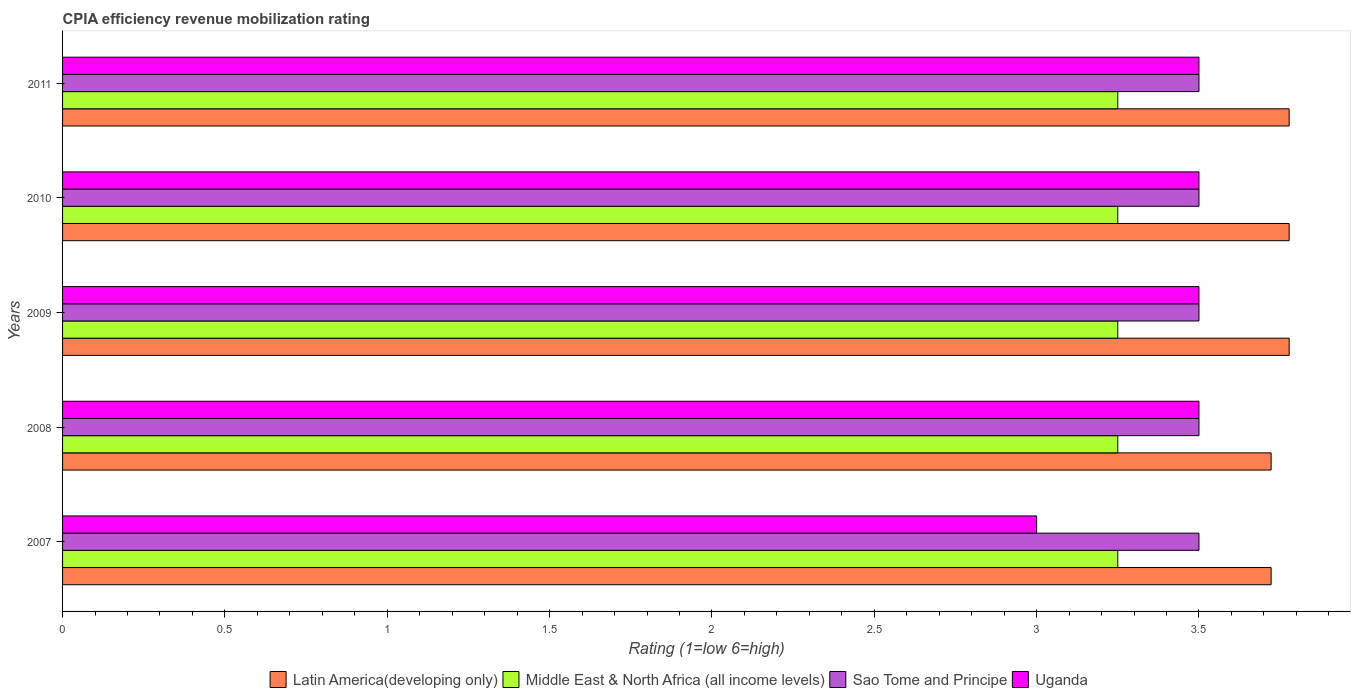How many different coloured bars are there?
Your answer should be very brief. 4. Are the number of bars on each tick of the Y-axis equal?
Offer a very short reply. Yes. How many bars are there on the 5th tick from the top?
Offer a very short reply. 4. Across all years, what is the minimum CPIA rating in Latin America(developing only)?
Give a very brief answer. 3.72. In which year was the CPIA rating in Uganda maximum?
Make the answer very short. 2008. In which year was the CPIA rating in Middle East & North Africa (all income levels) minimum?
Keep it short and to the point. 2007. What is the difference between the CPIA rating in Middle East & North Africa (all income levels) in 2007 and that in 2009?
Your answer should be compact. 0. What is the difference between the CPIA rating in Uganda in 2010 and the CPIA rating in Sao Tome and Principe in 2007?
Your answer should be very brief. 0. In the year 2008, what is the difference between the CPIA rating in Middle East & North Africa (all income levels) and CPIA rating in Sao Tome and Principe?
Offer a terse response. -0.25. What is the ratio of the CPIA rating in Middle East & North Africa (all income levels) in 2007 to that in 2011?
Give a very brief answer. 1. Is the CPIA rating in Latin America(developing only) in 2007 less than that in 2010?
Give a very brief answer. Yes. Is the difference between the CPIA rating in Middle East & North Africa (all income levels) in 2010 and 2011 greater than the difference between the CPIA rating in Sao Tome and Principe in 2010 and 2011?
Your response must be concise. No. What does the 1st bar from the top in 2007 represents?
Provide a short and direct response. Uganda. What does the 2nd bar from the bottom in 2011 represents?
Your answer should be compact. Middle East & North Africa (all income levels). Is it the case that in every year, the sum of the CPIA rating in Middle East & North Africa (all income levels) and CPIA rating in Uganda is greater than the CPIA rating in Sao Tome and Principe?
Keep it short and to the point. Yes. Are all the bars in the graph horizontal?
Make the answer very short. Yes. How many years are there in the graph?
Offer a terse response. 5. What is the difference between two consecutive major ticks on the X-axis?
Give a very brief answer. 0.5. How many legend labels are there?
Your answer should be compact. 4. How are the legend labels stacked?
Offer a terse response. Horizontal. What is the title of the graph?
Provide a succinct answer. CPIA efficiency revenue mobilization rating. What is the label or title of the X-axis?
Offer a very short reply. Rating (1=low 6=high). What is the label or title of the Y-axis?
Give a very brief answer. Years. What is the Rating (1=low 6=high) in Latin America(developing only) in 2007?
Make the answer very short. 3.72. What is the Rating (1=low 6=high) of Middle East & North Africa (all income levels) in 2007?
Offer a very short reply. 3.25. What is the Rating (1=low 6=high) in Sao Tome and Principe in 2007?
Provide a short and direct response. 3.5. What is the Rating (1=low 6=high) in Uganda in 2007?
Your answer should be very brief. 3. What is the Rating (1=low 6=high) in Latin America(developing only) in 2008?
Your response must be concise. 3.72. What is the Rating (1=low 6=high) of Uganda in 2008?
Give a very brief answer. 3.5. What is the Rating (1=low 6=high) of Latin America(developing only) in 2009?
Keep it short and to the point. 3.78. What is the Rating (1=low 6=high) in Latin America(developing only) in 2010?
Your answer should be compact. 3.78. What is the Rating (1=low 6=high) in Sao Tome and Principe in 2010?
Provide a succinct answer. 3.5. What is the Rating (1=low 6=high) of Latin America(developing only) in 2011?
Your response must be concise. 3.78. What is the Rating (1=low 6=high) of Middle East & North Africa (all income levels) in 2011?
Provide a short and direct response. 3.25. Across all years, what is the maximum Rating (1=low 6=high) of Latin America(developing only)?
Your response must be concise. 3.78. Across all years, what is the maximum Rating (1=low 6=high) of Middle East & North Africa (all income levels)?
Ensure brevity in your answer.  3.25. Across all years, what is the maximum Rating (1=low 6=high) in Uganda?
Your answer should be very brief. 3.5. Across all years, what is the minimum Rating (1=low 6=high) of Latin America(developing only)?
Give a very brief answer. 3.72. Across all years, what is the minimum Rating (1=low 6=high) of Middle East & North Africa (all income levels)?
Provide a short and direct response. 3.25. Across all years, what is the minimum Rating (1=low 6=high) of Sao Tome and Principe?
Offer a terse response. 3.5. Across all years, what is the minimum Rating (1=low 6=high) of Uganda?
Offer a terse response. 3. What is the total Rating (1=low 6=high) of Latin America(developing only) in the graph?
Give a very brief answer. 18.78. What is the total Rating (1=low 6=high) of Middle East & North Africa (all income levels) in the graph?
Your answer should be compact. 16.25. What is the total Rating (1=low 6=high) of Sao Tome and Principe in the graph?
Offer a terse response. 17.5. What is the total Rating (1=low 6=high) of Uganda in the graph?
Ensure brevity in your answer.  17. What is the difference between the Rating (1=low 6=high) of Uganda in 2007 and that in 2008?
Offer a very short reply. -0.5. What is the difference between the Rating (1=low 6=high) of Latin America(developing only) in 2007 and that in 2009?
Offer a very short reply. -0.06. What is the difference between the Rating (1=low 6=high) in Latin America(developing only) in 2007 and that in 2010?
Provide a short and direct response. -0.06. What is the difference between the Rating (1=low 6=high) in Sao Tome and Principe in 2007 and that in 2010?
Your answer should be very brief. 0. What is the difference between the Rating (1=low 6=high) in Latin America(developing only) in 2007 and that in 2011?
Offer a terse response. -0.06. What is the difference between the Rating (1=low 6=high) of Middle East & North Africa (all income levels) in 2007 and that in 2011?
Give a very brief answer. 0. What is the difference between the Rating (1=low 6=high) in Sao Tome and Principe in 2007 and that in 2011?
Your answer should be very brief. 0. What is the difference between the Rating (1=low 6=high) in Uganda in 2007 and that in 2011?
Offer a very short reply. -0.5. What is the difference between the Rating (1=low 6=high) of Latin America(developing only) in 2008 and that in 2009?
Make the answer very short. -0.06. What is the difference between the Rating (1=low 6=high) of Latin America(developing only) in 2008 and that in 2010?
Your answer should be compact. -0.06. What is the difference between the Rating (1=low 6=high) in Sao Tome and Principe in 2008 and that in 2010?
Make the answer very short. 0. What is the difference between the Rating (1=low 6=high) in Uganda in 2008 and that in 2010?
Ensure brevity in your answer.  0. What is the difference between the Rating (1=low 6=high) in Latin America(developing only) in 2008 and that in 2011?
Give a very brief answer. -0.06. What is the difference between the Rating (1=low 6=high) of Middle East & North Africa (all income levels) in 2009 and that in 2010?
Your answer should be compact. 0. What is the difference between the Rating (1=low 6=high) of Uganda in 2009 and that in 2010?
Make the answer very short. 0. What is the difference between the Rating (1=low 6=high) of Sao Tome and Principe in 2010 and that in 2011?
Give a very brief answer. 0. What is the difference between the Rating (1=low 6=high) in Uganda in 2010 and that in 2011?
Your response must be concise. 0. What is the difference between the Rating (1=low 6=high) of Latin America(developing only) in 2007 and the Rating (1=low 6=high) of Middle East & North Africa (all income levels) in 2008?
Ensure brevity in your answer.  0.47. What is the difference between the Rating (1=low 6=high) in Latin America(developing only) in 2007 and the Rating (1=low 6=high) in Sao Tome and Principe in 2008?
Offer a terse response. 0.22. What is the difference between the Rating (1=low 6=high) of Latin America(developing only) in 2007 and the Rating (1=low 6=high) of Uganda in 2008?
Provide a succinct answer. 0.22. What is the difference between the Rating (1=low 6=high) in Middle East & North Africa (all income levels) in 2007 and the Rating (1=low 6=high) in Sao Tome and Principe in 2008?
Make the answer very short. -0.25. What is the difference between the Rating (1=low 6=high) of Latin America(developing only) in 2007 and the Rating (1=low 6=high) of Middle East & North Africa (all income levels) in 2009?
Provide a short and direct response. 0.47. What is the difference between the Rating (1=low 6=high) in Latin America(developing only) in 2007 and the Rating (1=low 6=high) in Sao Tome and Principe in 2009?
Your answer should be very brief. 0.22. What is the difference between the Rating (1=low 6=high) of Latin America(developing only) in 2007 and the Rating (1=low 6=high) of Uganda in 2009?
Offer a terse response. 0.22. What is the difference between the Rating (1=low 6=high) of Middle East & North Africa (all income levels) in 2007 and the Rating (1=low 6=high) of Sao Tome and Principe in 2009?
Provide a succinct answer. -0.25. What is the difference between the Rating (1=low 6=high) in Latin America(developing only) in 2007 and the Rating (1=low 6=high) in Middle East & North Africa (all income levels) in 2010?
Your answer should be very brief. 0.47. What is the difference between the Rating (1=low 6=high) of Latin America(developing only) in 2007 and the Rating (1=low 6=high) of Sao Tome and Principe in 2010?
Keep it short and to the point. 0.22. What is the difference between the Rating (1=low 6=high) of Latin America(developing only) in 2007 and the Rating (1=low 6=high) of Uganda in 2010?
Provide a succinct answer. 0.22. What is the difference between the Rating (1=low 6=high) of Middle East & North Africa (all income levels) in 2007 and the Rating (1=low 6=high) of Uganda in 2010?
Give a very brief answer. -0.25. What is the difference between the Rating (1=low 6=high) of Latin America(developing only) in 2007 and the Rating (1=low 6=high) of Middle East & North Africa (all income levels) in 2011?
Your answer should be compact. 0.47. What is the difference between the Rating (1=low 6=high) of Latin America(developing only) in 2007 and the Rating (1=low 6=high) of Sao Tome and Principe in 2011?
Offer a very short reply. 0.22. What is the difference between the Rating (1=low 6=high) of Latin America(developing only) in 2007 and the Rating (1=low 6=high) of Uganda in 2011?
Ensure brevity in your answer.  0.22. What is the difference between the Rating (1=low 6=high) of Middle East & North Africa (all income levels) in 2007 and the Rating (1=low 6=high) of Sao Tome and Principe in 2011?
Your answer should be very brief. -0.25. What is the difference between the Rating (1=low 6=high) in Middle East & North Africa (all income levels) in 2007 and the Rating (1=low 6=high) in Uganda in 2011?
Your answer should be very brief. -0.25. What is the difference between the Rating (1=low 6=high) in Sao Tome and Principe in 2007 and the Rating (1=low 6=high) in Uganda in 2011?
Your answer should be very brief. 0. What is the difference between the Rating (1=low 6=high) of Latin America(developing only) in 2008 and the Rating (1=low 6=high) of Middle East & North Africa (all income levels) in 2009?
Your answer should be very brief. 0.47. What is the difference between the Rating (1=low 6=high) of Latin America(developing only) in 2008 and the Rating (1=low 6=high) of Sao Tome and Principe in 2009?
Your answer should be very brief. 0.22. What is the difference between the Rating (1=low 6=high) of Latin America(developing only) in 2008 and the Rating (1=low 6=high) of Uganda in 2009?
Keep it short and to the point. 0.22. What is the difference between the Rating (1=low 6=high) in Middle East & North Africa (all income levels) in 2008 and the Rating (1=low 6=high) in Sao Tome and Principe in 2009?
Give a very brief answer. -0.25. What is the difference between the Rating (1=low 6=high) in Middle East & North Africa (all income levels) in 2008 and the Rating (1=low 6=high) in Uganda in 2009?
Provide a succinct answer. -0.25. What is the difference between the Rating (1=low 6=high) of Sao Tome and Principe in 2008 and the Rating (1=low 6=high) of Uganda in 2009?
Your answer should be very brief. 0. What is the difference between the Rating (1=low 6=high) of Latin America(developing only) in 2008 and the Rating (1=low 6=high) of Middle East & North Africa (all income levels) in 2010?
Keep it short and to the point. 0.47. What is the difference between the Rating (1=low 6=high) of Latin America(developing only) in 2008 and the Rating (1=low 6=high) of Sao Tome and Principe in 2010?
Your answer should be compact. 0.22. What is the difference between the Rating (1=low 6=high) of Latin America(developing only) in 2008 and the Rating (1=low 6=high) of Uganda in 2010?
Ensure brevity in your answer.  0.22. What is the difference between the Rating (1=low 6=high) in Middle East & North Africa (all income levels) in 2008 and the Rating (1=low 6=high) in Sao Tome and Principe in 2010?
Keep it short and to the point. -0.25. What is the difference between the Rating (1=low 6=high) in Sao Tome and Principe in 2008 and the Rating (1=low 6=high) in Uganda in 2010?
Your response must be concise. 0. What is the difference between the Rating (1=low 6=high) of Latin America(developing only) in 2008 and the Rating (1=low 6=high) of Middle East & North Africa (all income levels) in 2011?
Keep it short and to the point. 0.47. What is the difference between the Rating (1=low 6=high) in Latin America(developing only) in 2008 and the Rating (1=low 6=high) in Sao Tome and Principe in 2011?
Offer a terse response. 0.22. What is the difference between the Rating (1=low 6=high) in Latin America(developing only) in 2008 and the Rating (1=low 6=high) in Uganda in 2011?
Give a very brief answer. 0.22. What is the difference between the Rating (1=low 6=high) in Latin America(developing only) in 2009 and the Rating (1=low 6=high) in Middle East & North Africa (all income levels) in 2010?
Your answer should be compact. 0.53. What is the difference between the Rating (1=low 6=high) in Latin America(developing only) in 2009 and the Rating (1=low 6=high) in Sao Tome and Principe in 2010?
Offer a very short reply. 0.28. What is the difference between the Rating (1=low 6=high) in Latin America(developing only) in 2009 and the Rating (1=low 6=high) in Uganda in 2010?
Ensure brevity in your answer.  0.28. What is the difference between the Rating (1=low 6=high) of Latin America(developing only) in 2009 and the Rating (1=low 6=high) of Middle East & North Africa (all income levels) in 2011?
Offer a very short reply. 0.53. What is the difference between the Rating (1=low 6=high) in Latin America(developing only) in 2009 and the Rating (1=low 6=high) in Sao Tome and Principe in 2011?
Make the answer very short. 0.28. What is the difference between the Rating (1=low 6=high) in Latin America(developing only) in 2009 and the Rating (1=low 6=high) in Uganda in 2011?
Offer a very short reply. 0.28. What is the difference between the Rating (1=low 6=high) of Middle East & North Africa (all income levels) in 2009 and the Rating (1=low 6=high) of Sao Tome and Principe in 2011?
Ensure brevity in your answer.  -0.25. What is the difference between the Rating (1=low 6=high) of Latin America(developing only) in 2010 and the Rating (1=low 6=high) of Middle East & North Africa (all income levels) in 2011?
Provide a succinct answer. 0.53. What is the difference between the Rating (1=low 6=high) of Latin America(developing only) in 2010 and the Rating (1=low 6=high) of Sao Tome and Principe in 2011?
Make the answer very short. 0.28. What is the difference between the Rating (1=low 6=high) of Latin America(developing only) in 2010 and the Rating (1=low 6=high) of Uganda in 2011?
Keep it short and to the point. 0.28. What is the difference between the Rating (1=low 6=high) of Middle East & North Africa (all income levels) in 2010 and the Rating (1=low 6=high) of Sao Tome and Principe in 2011?
Offer a very short reply. -0.25. What is the average Rating (1=low 6=high) of Latin America(developing only) per year?
Keep it short and to the point. 3.76. In the year 2007, what is the difference between the Rating (1=low 6=high) in Latin America(developing only) and Rating (1=low 6=high) in Middle East & North Africa (all income levels)?
Keep it short and to the point. 0.47. In the year 2007, what is the difference between the Rating (1=low 6=high) in Latin America(developing only) and Rating (1=low 6=high) in Sao Tome and Principe?
Ensure brevity in your answer.  0.22. In the year 2007, what is the difference between the Rating (1=low 6=high) of Latin America(developing only) and Rating (1=low 6=high) of Uganda?
Ensure brevity in your answer.  0.72. In the year 2007, what is the difference between the Rating (1=low 6=high) in Middle East & North Africa (all income levels) and Rating (1=low 6=high) in Sao Tome and Principe?
Provide a short and direct response. -0.25. In the year 2007, what is the difference between the Rating (1=low 6=high) of Sao Tome and Principe and Rating (1=low 6=high) of Uganda?
Your answer should be very brief. 0.5. In the year 2008, what is the difference between the Rating (1=low 6=high) in Latin America(developing only) and Rating (1=low 6=high) in Middle East & North Africa (all income levels)?
Provide a succinct answer. 0.47. In the year 2008, what is the difference between the Rating (1=low 6=high) of Latin America(developing only) and Rating (1=low 6=high) of Sao Tome and Principe?
Your answer should be compact. 0.22. In the year 2008, what is the difference between the Rating (1=low 6=high) in Latin America(developing only) and Rating (1=low 6=high) in Uganda?
Offer a terse response. 0.22. In the year 2008, what is the difference between the Rating (1=low 6=high) of Middle East & North Africa (all income levels) and Rating (1=low 6=high) of Sao Tome and Principe?
Provide a short and direct response. -0.25. In the year 2008, what is the difference between the Rating (1=low 6=high) of Middle East & North Africa (all income levels) and Rating (1=low 6=high) of Uganda?
Provide a succinct answer. -0.25. In the year 2008, what is the difference between the Rating (1=low 6=high) in Sao Tome and Principe and Rating (1=low 6=high) in Uganda?
Give a very brief answer. 0. In the year 2009, what is the difference between the Rating (1=low 6=high) of Latin America(developing only) and Rating (1=low 6=high) of Middle East & North Africa (all income levels)?
Your response must be concise. 0.53. In the year 2009, what is the difference between the Rating (1=low 6=high) in Latin America(developing only) and Rating (1=low 6=high) in Sao Tome and Principe?
Provide a short and direct response. 0.28. In the year 2009, what is the difference between the Rating (1=low 6=high) in Latin America(developing only) and Rating (1=low 6=high) in Uganda?
Offer a terse response. 0.28. In the year 2009, what is the difference between the Rating (1=low 6=high) of Sao Tome and Principe and Rating (1=low 6=high) of Uganda?
Make the answer very short. 0. In the year 2010, what is the difference between the Rating (1=low 6=high) of Latin America(developing only) and Rating (1=low 6=high) of Middle East & North Africa (all income levels)?
Offer a terse response. 0.53. In the year 2010, what is the difference between the Rating (1=low 6=high) of Latin America(developing only) and Rating (1=low 6=high) of Sao Tome and Principe?
Your answer should be compact. 0.28. In the year 2010, what is the difference between the Rating (1=low 6=high) of Latin America(developing only) and Rating (1=low 6=high) of Uganda?
Your answer should be very brief. 0.28. In the year 2010, what is the difference between the Rating (1=low 6=high) in Middle East & North Africa (all income levels) and Rating (1=low 6=high) in Uganda?
Your answer should be compact. -0.25. In the year 2011, what is the difference between the Rating (1=low 6=high) of Latin America(developing only) and Rating (1=low 6=high) of Middle East & North Africa (all income levels)?
Keep it short and to the point. 0.53. In the year 2011, what is the difference between the Rating (1=low 6=high) of Latin America(developing only) and Rating (1=low 6=high) of Sao Tome and Principe?
Your answer should be compact. 0.28. In the year 2011, what is the difference between the Rating (1=low 6=high) of Latin America(developing only) and Rating (1=low 6=high) of Uganda?
Give a very brief answer. 0.28. In the year 2011, what is the difference between the Rating (1=low 6=high) in Middle East & North Africa (all income levels) and Rating (1=low 6=high) in Sao Tome and Principe?
Your response must be concise. -0.25. In the year 2011, what is the difference between the Rating (1=low 6=high) in Middle East & North Africa (all income levels) and Rating (1=low 6=high) in Uganda?
Ensure brevity in your answer.  -0.25. In the year 2011, what is the difference between the Rating (1=low 6=high) of Sao Tome and Principe and Rating (1=low 6=high) of Uganda?
Provide a succinct answer. 0. What is the ratio of the Rating (1=low 6=high) in Middle East & North Africa (all income levels) in 2007 to that in 2008?
Your answer should be very brief. 1. What is the ratio of the Rating (1=low 6=high) in Middle East & North Africa (all income levels) in 2007 to that in 2009?
Provide a succinct answer. 1. What is the ratio of the Rating (1=low 6=high) in Sao Tome and Principe in 2007 to that in 2009?
Your response must be concise. 1. What is the ratio of the Rating (1=low 6=high) in Latin America(developing only) in 2007 to that in 2010?
Keep it short and to the point. 0.99. What is the ratio of the Rating (1=low 6=high) in Sao Tome and Principe in 2007 to that in 2010?
Provide a succinct answer. 1. What is the ratio of the Rating (1=low 6=high) in Latin America(developing only) in 2007 to that in 2011?
Offer a terse response. 0.99. What is the ratio of the Rating (1=low 6=high) of Middle East & North Africa (all income levels) in 2007 to that in 2011?
Offer a very short reply. 1. What is the ratio of the Rating (1=low 6=high) in Sao Tome and Principe in 2007 to that in 2011?
Offer a very short reply. 1. What is the ratio of the Rating (1=low 6=high) in Middle East & North Africa (all income levels) in 2008 to that in 2009?
Offer a very short reply. 1. What is the ratio of the Rating (1=low 6=high) in Sao Tome and Principe in 2008 to that in 2009?
Keep it short and to the point. 1. What is the ratio of the Rating (1=low 6=high) in Uganda in 2008 to that in 2009?
Provide a short and direct response. 1. What is the ratio of the Rating (1=low 6=high) of Middle East & North Africa (all income levels) in 2008 to that in 2010?
Offer a terse response. 1. What is the ratio of the Rating (1=low 6=high) in Uganda in 2008 to that in 2010?
Your answer should be compact. 1. What is the ratio of the Rating (1=low 6=high) in Latin America(developing only) in 2008 to that in 2011?
Your response must be concise. 0.99. What is the ratio of the Rating (1=low 6=high) of Middle East & North Africa (all income levels) in 2008 to that in 2011?
Provide a short and direct response. 1. What is the ratio of the Rating (1=low 6=high) in Sao Tome and Principe in 2008 to that in 2011?
Offer a terse response. 1. What is the ratio of the Rating (1=low 6=high) in Uganda in 2008 to that in 2011?
Provide a short and direct response. 1. What is the ratio of the Rating (1=low 6=high) in Uganda in 2009 to that in 2010?
Provide a succinct answer. 1. What is the ratio of the Rating (1=low 6=high) of Latin America(developing only) in 2009 to that in 2011?
Offer a very short reply. 1. What is the ratio of the Rating (1=low 6=high) of Middle East & North Africa (all income levels) in 2009 to that in 2011?
Ensure brevity in your answer.  1. What is the ratio of the Rating (1=low 6=high) of Uganda in 2009 to that in 2011?
Offer a terse response. 1. What is the ratio of the Rating (1=low 6=high) in Uganda in 2010 to that in 2011?
Ensure brevity in your answer.  1. What is the difference between the highest and the second highest Rating (1=low 6=high) in Latin America(developing only)?
Your answer should be compact. 0. What is the difference between the highest and the second highest Rating (1=low 6=high) in Middle East & North Africa (all income levels)?
Provide a short and direct response. 0. What is the difference between the highest and the lowest Rating (1=low 6=high) in Latin America(developing only)?
Give a very brief answer. 0.06. What is the difference between the highest and the lowest Rating (1=low 6=high) of Middle East & North Africa (all income levels)?
Provide a short and direct response. 0. What is the difference between the highest and the lowest Rating (1=low 6=high) in Sao Tome and Principe?
Provide a short and direct response. 0. What is the difference between the highest and the lowest Rating (1=low 6=high) in Uganda?
Your answer should be very brief. 0.5. 